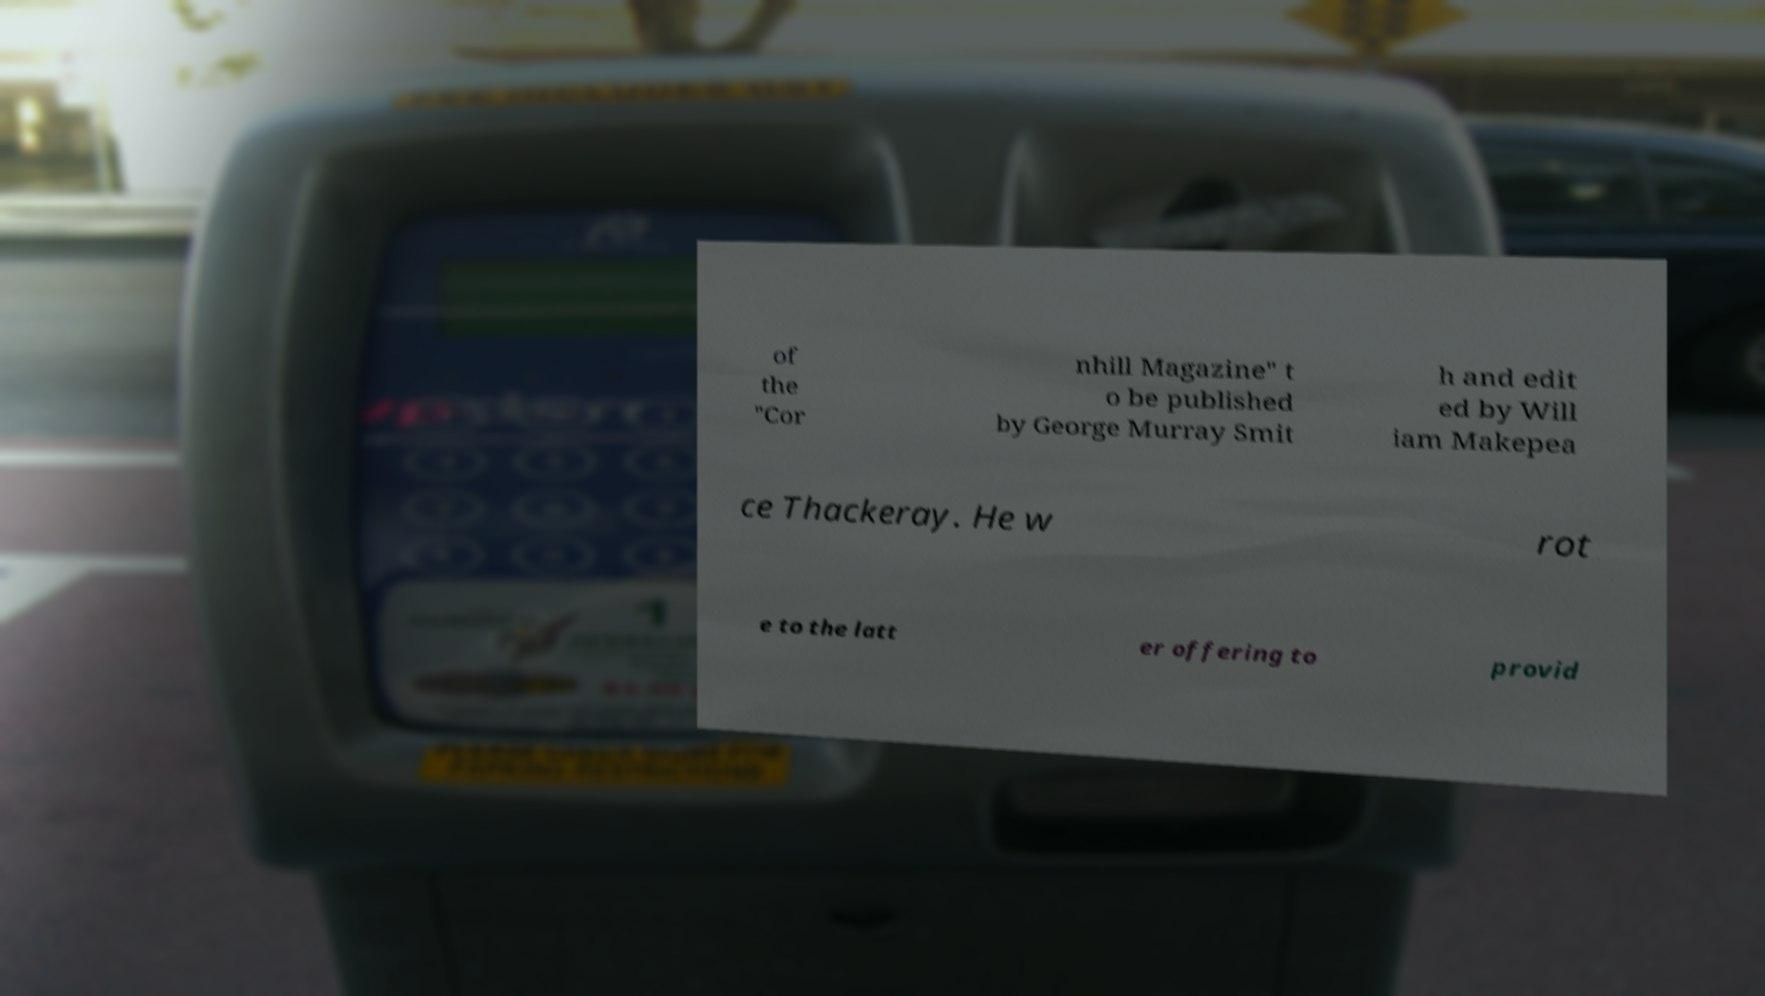There's text embedded in this image that I need extracted. Can you transcribe it verbatim? of the "Cor nhill Magazine" t o be published by George Murray Smit h and edit ed by Will iam Makepea ce Thackeray. He w rot e to the latt er offering to provid 